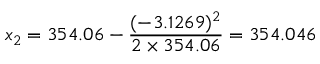<formula> <loc_0><loc_0><loc_500><loc_500>x _ { 2 } = 3 5 4 . 0 6 - { \frac { ( - 3 . 1 2 6 9 ) ^ { 2 } } { 2 \times 3 5 4 . 0 6 } } = 3 5 4 . 0 4 6</formula> 